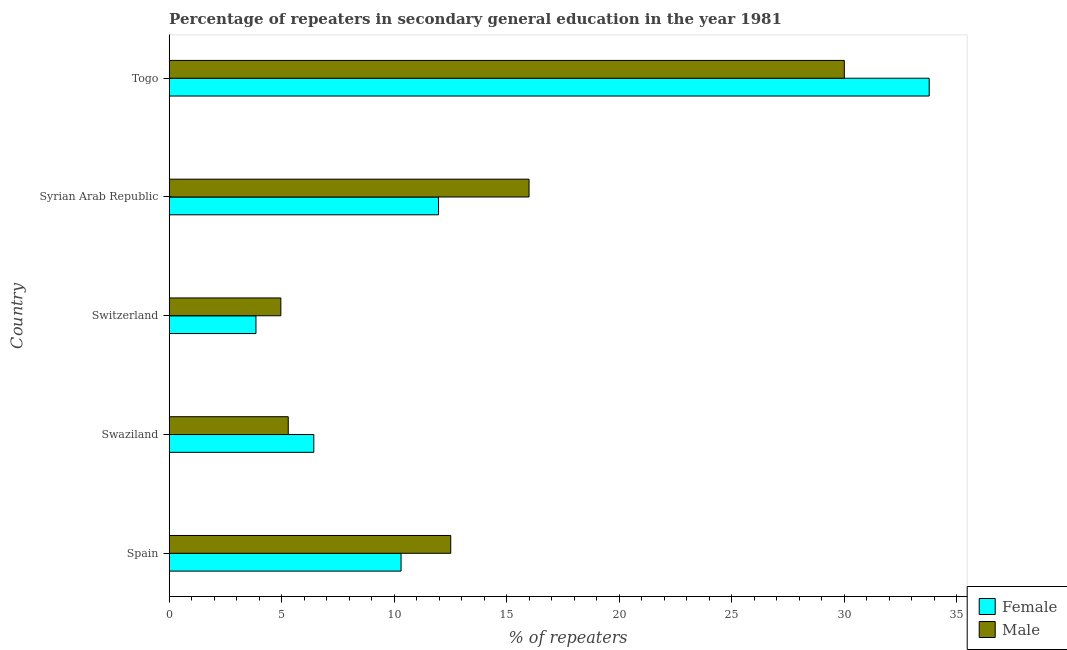How many different coloured bars are there?
Provide a short and direct response. 2. How many groups of bars are there?
Offer a terse response. 5. How many bars are there on the 4th tick from the top?
Ensure brevity in your answer.  2. What is the label of the 2nd group of bars from the top?
Your answer should be compact. Syrian Arab Republic. In how many cases, is the number of bars for a given country not equal to the number of legend labels?
Offer a very short reply. 0. What is the percentage of male repeaters in Syrian Arab Republic?
Your response must be concise. 15.99. Across all countries, what is the maximum percentage of female repeaters?
Provide a succinct answer. 33.77. Across all countries, what is the minimum percentage of female repeaters?
Your answer should be compact. 3.85. In which country was the percentage of female repeaters maximum?
Provide a succinct answer. Togo. In which country was the percentage of female repeaters minimum?
Provide a short and direct response. Switzerland. What is the total percentage of female repeaters in the graph?
Offer a terse response. 66.31. What is the difference between the percentage of male repeaters in Switzerland and that in Togo?
Make the answer very short. -25.04. What is the difference between the percentage of male repeaters in Togo and the percentage of female repeaters in Switzerland?
Give a very brief answer. 26.14. What is the average percentage of female repeaters per country?
Give a very brief answer. 13.26. What is the difference between the percentage of female repeaters and percentage of male repeaters in Syrian Arab Republic?
Offer a terse response. -4.02. In how many countries, is the percentage of male repeaters greater than 7 %?
Your answer should be very brief. 3. What is the ratio of the percentage of male repeaters in Swaziland to that in Switzerland?
Provide a short and direct response. 1.07. Is the difference between the percentage of female repeaters in Spain and Syrian Arab Republic greater than the difference between the percentage of male repeaters in Spain and Syrian Arab Republic?
Your response must be concise. Yes. What is the difference between the highest and the second highest percentage of female repeaters?
Offer a very short reply. 21.8. What is the difference between the highest and the lowest percentage of female repeaters?
Ensure brevity in your answer.  29.91. In how many countries, is the percentage of female repeaters greater than the average percentage of female repeaters taken over all countries?
Your answer should be very brief. 1. Is the sum of the percentage of male repeaters in Swaziland and Togo greater than the maximum percentage of female repeaters across all countries?
Offer a terse response. Yes. What does the 2nd bar from the bottom in Togo represents?
Provide a succinct answer. Male. How many bars are there?
Your response must be concise. 10. Are the values on the major ticks of X-axis written in scientific E-notation?
Your answer should be compact. No. Does the graph contain grids?
Your answer should be compact. No. How many legend labels are there?
Your answer should be very brief. 2. How are the legend labels stacked?
Offer a terse response. Vertical. What is the title of the graph?
Provide a short and direct response. Percentage of repeaters in secondary general education in the year 1981. What is the label or title of the X-axis?
Your answer should be very brief. % of repeaters. What is the label or title of the Y-axis?
Offer a very short reply. Country. What is the % of repeaters of Female in Spain?
Make the answer very short. 10.3. What is the % of repeaters of Male in Spain?
Give a very brief answer. 12.51. What is the % of repeaters of Female in Swaziland?
Keep it short and to the point. 6.42. What is the % of repeaters of Male in Swaziland?
Keep it short and to the point. 5.29. What is the % of repeaters in Female in Switzerland?
Offer a very short reply. 3.85. What is the % of repeaters in Male in Switzerland?
Your response must be concise. 4.96. What is the % of repeaters of Female in Syrian Arab Republic?
Make the answer very short. 11.97. What is the % of repeaters of Male in Syrian Arab Republic?
Offer a very short reply. 15.99. What is the % of repeaters in Female in Togo?
Your answer should be compact. 33.77. What is the % of repeaters of Male in Togo?
Give a very brief answer. 29.99. Across all countries, what is the maximum % of repeaters in Female?
Offer a terse response. 33.77. Across all countries, what is the maximum % of repeaters of Male?
Provide a succinct answer. 29.99. Across all countries, what is the minimum % of repeaters of Female?
Your answer should be very brief. 3.85. Across all countries, what is the minimum % of repeaters of Male?
Keep it short and to the point. 4.96. What is the total % of repeaters of Female in the graph?
Your answer should be compact. 66.31. What is the total % of repeaters of Male in the graph?
Give a very brief answer. 68.74. What is the difference between the % of repeaters in Female in Spain and that in Swaziland?
Make the answer very short. 3.88. What is the difference between the % of repeaters in Male in Spain and that in Swaziland?
Your response must be concise. 7.22. What is the difference between the % of repeaters in Female in Spain and that in Switzerland?
Make the answer very short. 6.45. What is the difference between the % of repeaters of Male in Spain and that in Switzerland?
Give a very brief answer. 7.55. What is the difference between the % of repeaters in Female in Spain and that in Syrian Arab Republic?
Your answer should be very brief. -1.67. What is the difference between the % of repeaters of Male in Spain and that in Syrian Arab Republic?
Offer a terse response. -3.48. What is the difference between the % of repeaters in Female in Spain and that in Togo?
Offer a very short reply. -23.46. What is the difference between the % of repeaters in Male in Spain and that in Togo?
Ensure brevity in your answer.  -17.49. What is the difference between the % of repeaters of Female in Swaziland and that in Switzerland?
Keep it short and to the point. 2.57. What is the difference between the % of repeaters of Male in Swaziland and that in Switzerland?
Offer a terse response. 0.33. What is the difference between the % of repeaters of Female in Swaziland and that in Syrian Arab Republic?
Ensure brevity in your answer.  -5.54. What is the difference between the % of repeaters in Male in Swaziland and that in Syrian Arab Republic?
Make the answer very short. -10.7. What is the difference between the % of repeaters of Female in Swaziland and that in Togo?
Your answer should be very brief. -27.34. What is the difference between the % of repeaters in Male in Swaziland and that in Togo?
Your answer should be compact. -24.71. What is the difference between the % of repeaters in Female in Switzerland and that in Syrian Arab Republic?
Your response must be concise. -8.11. What is the difference between the % of repeaters of Male in Switzerland and that in Syrian Arab Republic?
Give a very brief answer. -11.03. What is the difference between the % of repeaters of Female in Switzerland and that in Togo?
Offer a terse response. -29.91. What is the difference between the % of repeaters of Male in Switzerland and that in Togo?
Ensure brevity in your answer.  -25.04. What is the difference between the % of repeaters of Female in Syrian Arab Republic and that in Togo?
Your answer should be compact. -21.8. What is the difference between the % of repeaters in Male in Syrian Arab Republic and that in Togo?
Offer a terse response. -14.01. What is the difference between the % of repeaters in Female in Spain and the % of repeaters in Male in Swaziland?
Provide a succinct answer. 5.01. What is the difference between the % of repeaters of Female in Spain and the % of repeaters of Male in Switzerland?
Make the answer very short. 5.34. What is the difference between the % of repeaters of Female in Spain and the % of repeaters of Male in Syrian Arab Republic?
Your response must be concise. -5.69. What is the difference between the % of repeaters of Female in Spain and the % of repeaters of Male in Togo?
Offer a terse response. -19.69. What is the difference between the % of repeaters of Female in Swaziland and the % of repeaters of Male in Switzerland?
Your response must be concise. 1.46. What is the difference between the % of repeaters of Female in Swaziland and the % of repeaters of Male in Syrian Arab Republic?
Offer a terse response. -9.56. What is the difference between the % of repeaters of Female in Swaziland and the % of repeaters of Male in Togo?
Provide a short and direct response. -23.57. What is the difference between the % of repeaters in Female in Switzerland and the % of repeaters in Male in Syrian Arab Republic?
Offer a terse response. -12.13. What is the difference between the % of repeaters of Female in Switzerland and the % of repeaters of Male in Togo?
Keep it short and to the point. -26.14. What is the difference between the % of repeaters in Female in Syrian Arab Republic and the % of repeaters in Male in Togo?
Provide a short and direct response. -18.03. What is the average % of repeaters of Female per country?
Your answer should be compact. 13.26. What is the average % of repeaters in Male per country?
Your response must be concise. 13.75. What is the difference between the % of repeaters of Female and % of repeaters of Male in Spain?
Keep it short and to the point. -2.21. What is the difference between the % of repeaters of Female and % of repeaters of Male in Swaziland?
Provide a succinct answer. 1.14. What is the difference between the % of repeaters of Female and % of repeaters of Male in Switzerland?
Provide a succinct answer. -1.11. What is the difference between the % of repeaters in Female and % of repeaters in Male in Syrian Arab Republic?
Make the answer very short. -4.02. What is the difference between the % of repeaters of Female and % of repeaters of Male in Togo?
Your response must be concise. 3.77. What is the ratio of the % of repeaters in Female in Spain to that in Swaziland?
Offer a terse response. 1.6. What is the ratio of the % of repeaters in Male in Spain to that in Swaziland?
Provide a short and direct response. 2.36. What is the ratio of the % of repeaters in Female in Spain to that in Switzerland?
Your response must be concise. 2.67. What is the ratio of the % of repeaters of Male in Spain to that in Switzerland?
Your response must be concise. 2.52. What is the ratio of the % of repeaters in Female in Spain to that in Syrian Arab Republic?
Your answer should be very brief. 0.86. What is the ratio of the % of repeaters of Male in Spain to that in Syrian Arab Republic?
Offer a very short reply. 0.78. What is the ratio of the % of repeaters in Female in Spain to that in Togo?
Offer a very short reply. 0.31. What is the ratio of the % of repeaters in Male in Spain to that in Togo?
Your response must be concise. 0.42. What is the ratio of the % of repeaters in Female in Swaziland to that in Switzerland?
Provide a succinct answer. 1.67. What is the ratio of the % of repeaters in Male in Swaziland to that in Switzerland?
Keep it short and to the point. 1.07. What is the ratio of the % of repeaters of Female in Swaziland to that in Syrian Arab Republic?
Your response must be concise. 0.54. What is the ratio of the % of repeaters in Male in Swaziland to that in Syrian Arab Republic?
Make the answer very short. 0.33. What is the ratio of the % of repeaters in Female in Swaziland to that in Togo?
Offer a very short reply. 0.19. What is the ratio of the % of repeaters of Male in Swaziland to that in Togo?
Your response must be concise. 0.18. What is the ratio of the % of repeaters in Female in Switzerland to that in Syrian Arab Republic?
Your answer should be very brief. 0.32. What is the ratio of the % of repeaters in Male in Switzerland to that in Syrian Arab Republic?
Provide a short and direct response. 0.31. What is the ratio of the % of repeaters in Female in Switzerland to that in Togo?
Your response must be concise. 0.11. What is the ratio of the % of repeaters in Male in Switzerland to that in Togo?
Keep it short and to the point. 0.17. What is the ratio of the % of repeaters in Female in Syrian Arab Republic to that in Togo?
Offer a terse response. 0.35. What is the ratio of the % of repeaters in Male in Syrian Arab Republic to that in Togo?
Ensure brevity in your answer.  0.53. What is the difference between the highest and the second highest % of repeaters of Female?
Give a very brief answer. 21.8. What is the difference between the highest and the second highest % of repeaters in Male?
Your answer should be very brief. 14.01. What is the difference between the highest and the lowest % of repeaters in Female?
Provide a succinct answer. 29.91. What is the difference between the highest and the lowest % of repeaters in Male?
Provide a short and direct response. 25.04. 